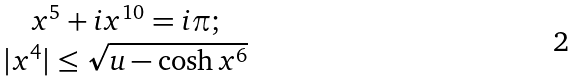Convert formula to latex. <formula><loc_0><loc_0><loc_500><loc_500>\begin{array} { c } x ^ { 5 } + i x ^ { 1 0 } = i \pi ; \\ | x ^ { 4 } | \leq \sqrt { u - \cosh x ^ { 6 } } \end{array}</formula> 